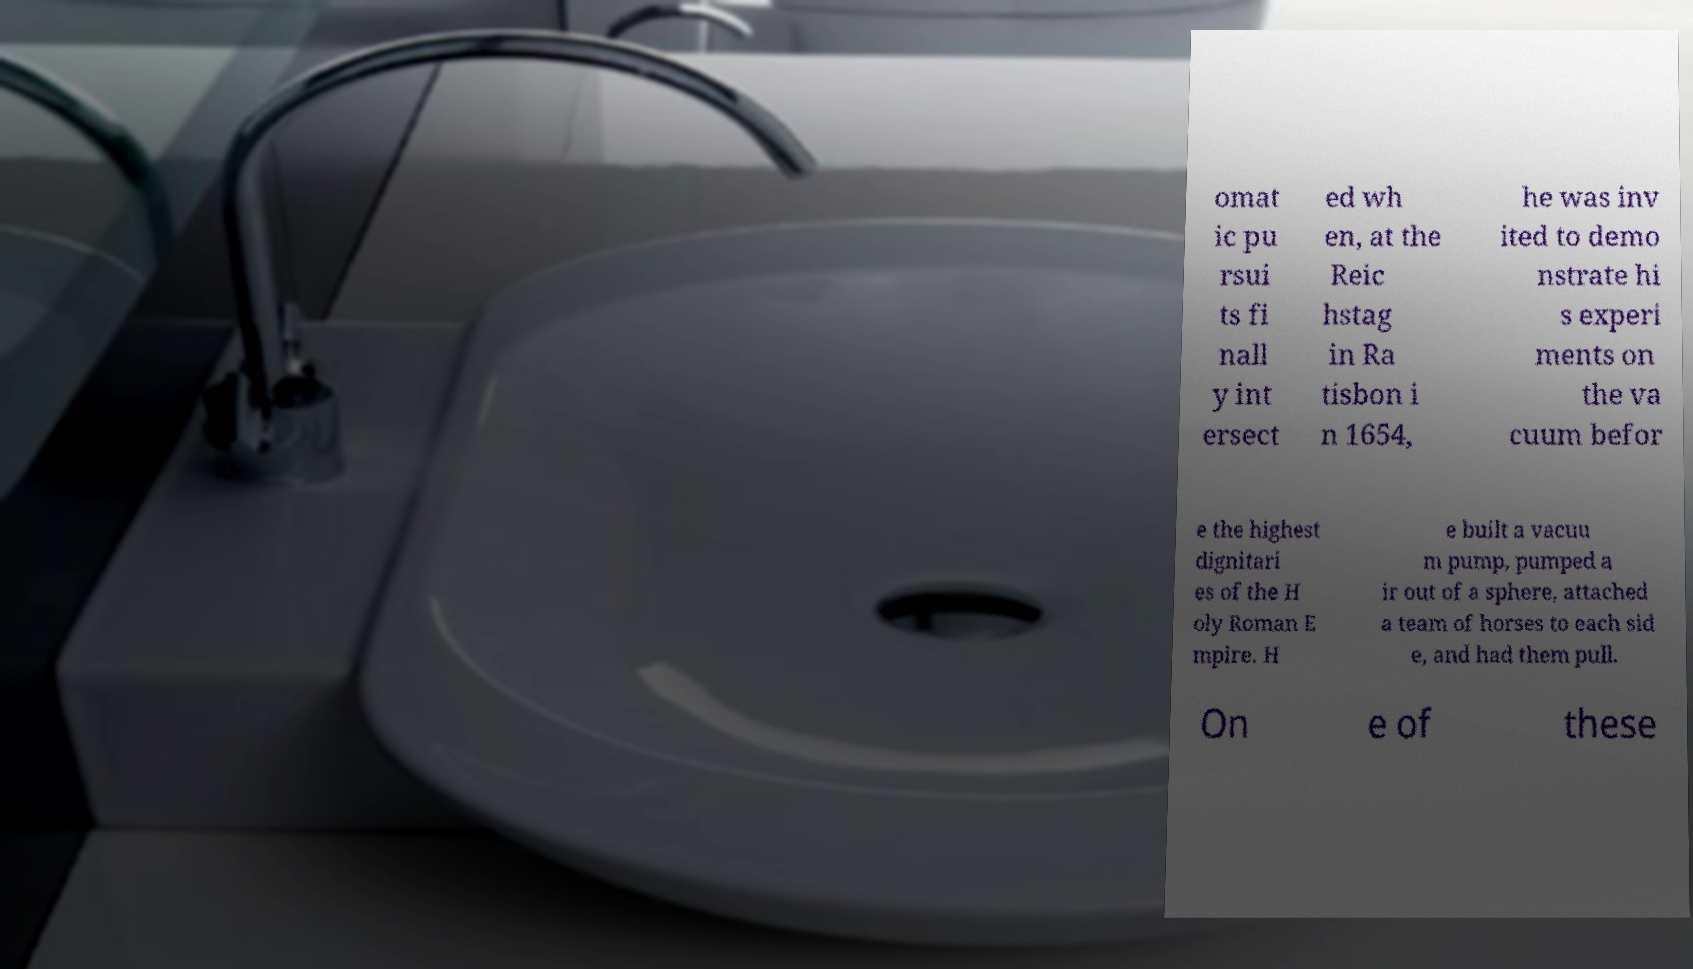For documentation purposes, I need the text within this image transcribed. Could you provide that? omat ic pu rsui ts fi nall y int ersect ed wh en, at the Reic hstag in Ra tisbon i n 1654, he was inv ited to demo nstrate hi s experi ments on the va cuum befor e the highest dignitari es of the H oly Roman E mpire. H e built a vacuu m pump, pumped a ir out of a sphere, attached a team of horses to each sid e, and had them pull. On e of these 